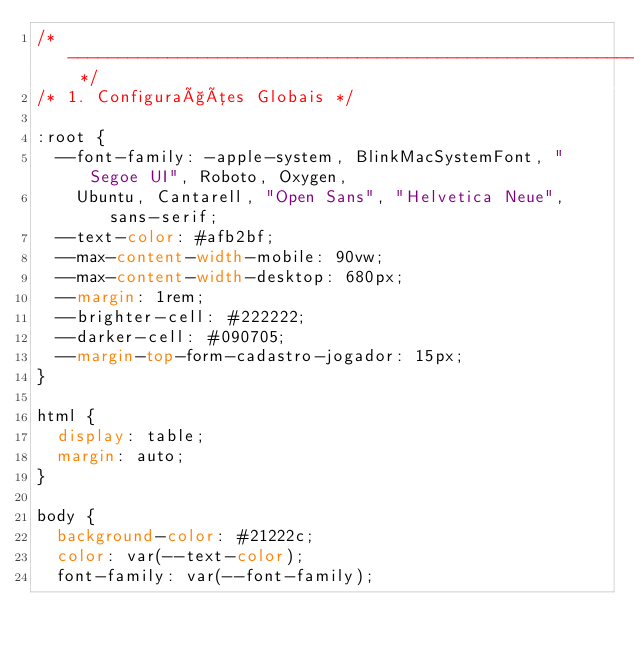Convert code to text. <code><loc_0><loc_0><loc_500><loc_500><_CSS_>/* -------------------------------------------------------------------------- */
/* 1. Configurações Globais */

:root {
  --font-family: -apple-system, BlinkMacSystemFont, "Segoe UI", Roboto, Oxygen,
    Ubuntu, Cantarell, "Open Sans", "Helvetica Neue", sans-serif;
  --text-color: #afb2bf;
  --max-content-width-mobile: 90vw;
  --max-content-width-desktop: 680px;
  --margin: 1rem;
  --brighter-cell: #222222;
  --darker-cell: #090705;
  --margin-top-form-cadastro-jogador: 15px;
}

html {
  display: table;
  margin: auto;
}

body {
  background-color: #21222c;
  color: var(--text-color);
  font-family: var(--font-family);</code> 